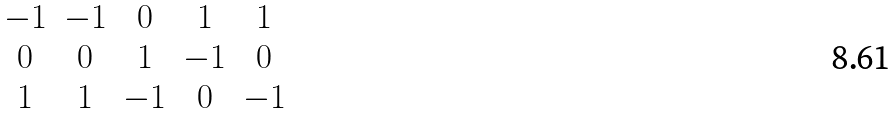<formula> <loc_0><loc_0><loc_500><loc_500>\begin{matrix} - 1 & - 1 & 0 & 1 & 1 \\ 0 & 0 & 1 & - 1 & 0 \\ 1 & 1 & - 1 & 0 & - 1 \end{matrix}</formula> 